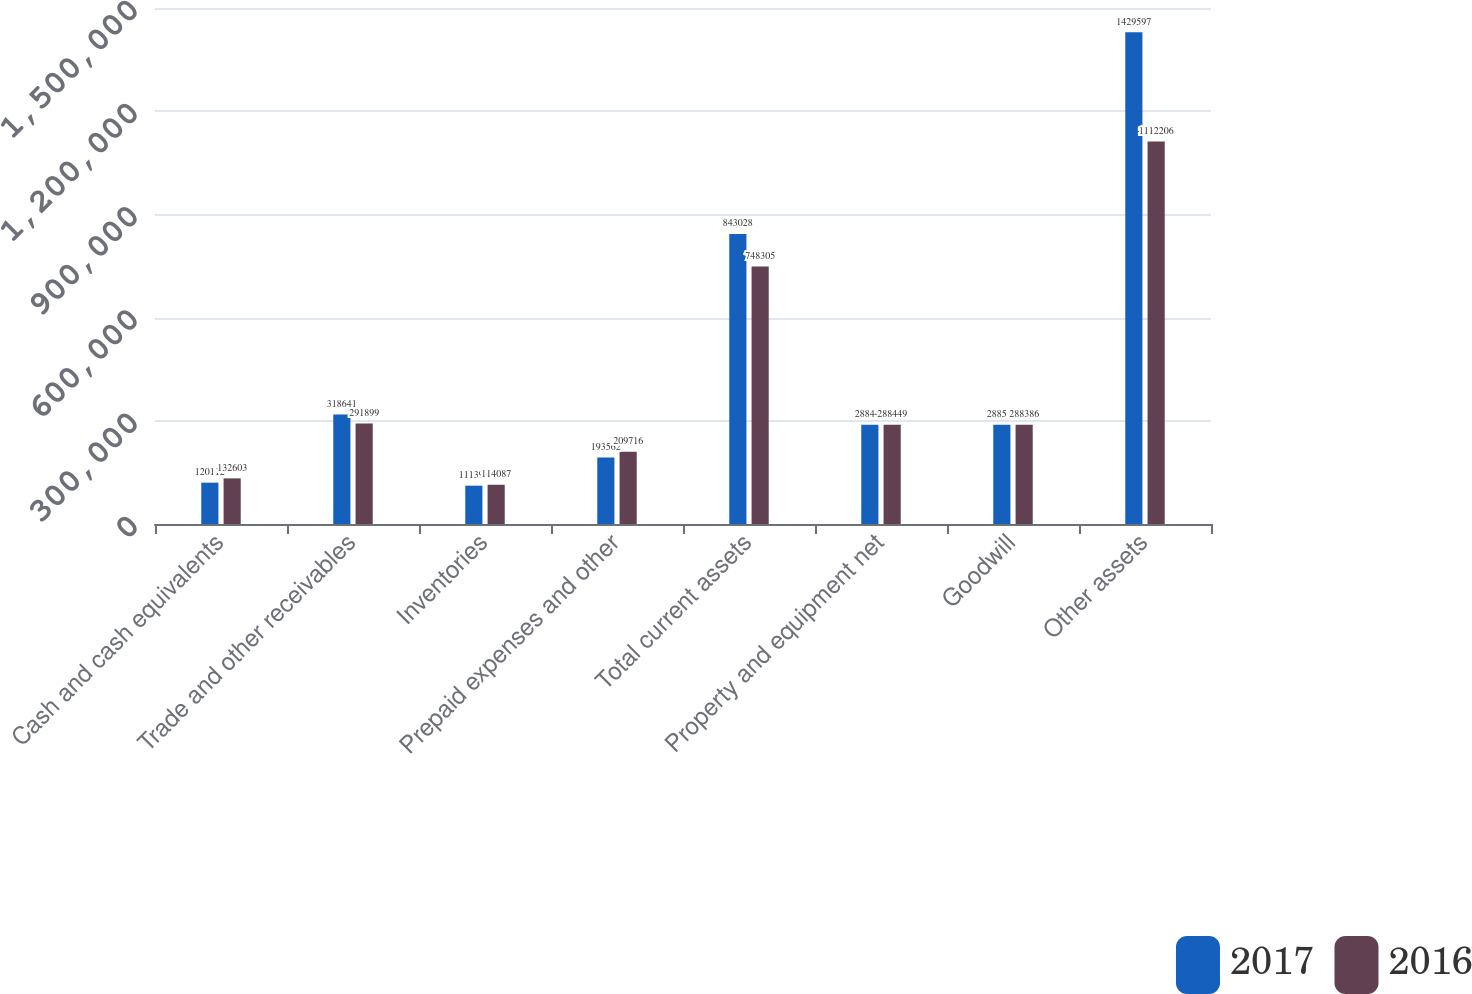<chart> <loc_0><loc_0><loc_500><loc_500><stacked_bar_chart><ecel><fcel>Cash and cash equivalents<fcel>Trade and other receivables<fcel>Inventories<fcel>Prepaid expenses and other<fcel>Total current assets<fcel>Property and equipment net<fcel>Goodwill<fcel>Other assets<nl><fcel>2017<fcel>120112<fcel>318641<fcel>111393<fcel>193562<fcel>843028<fcel>288449<fcel>288512<fcel>1.4296e+06<nl><fcel>2016<fcel>132603<fcel>291899<fcel>114087<fcel>209716<fcel>748305<fcel>288449<fcel>288386<fcel>1.11221e+06<nl></chart> 